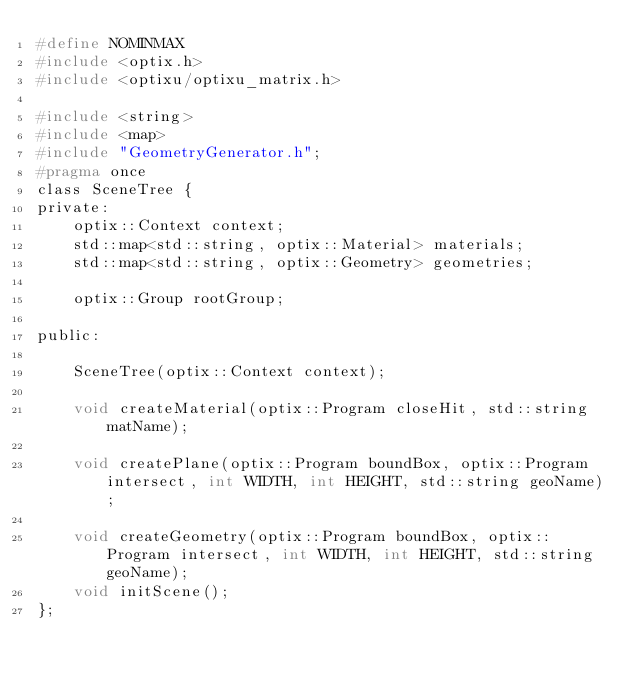Convert code to text. <code><loc_0><loc_0><loc_500><loc_500><_C_>#define NOMINMAX
#include <optix.h>
#include <optixu/optixu_matrix.h>

#include <string>
#include <map>
#include "GeometryGenerator.h";
#pragma once
class SceneTree {
private:
	optix::Context context;
	std::map<std::string, optix::Material> materials;
	std::map<std::string, optix::Geometry> geometries;

	optix::Group rootGroup;

public:

	SceneTree(optix::Context context);

	void createMaterial(optix::Program closeHit, std::string matName);

	void createPlane(optix::Program boundBox, optix::Program intersect, int WIDTH, int HEIGHT, std::string geoName);

	void createGeometry(optix::Program boundBox, optix::Program intersect, int WIDTH, int HEIGHT, std::string geoName);
	void initScene();
};</code> 